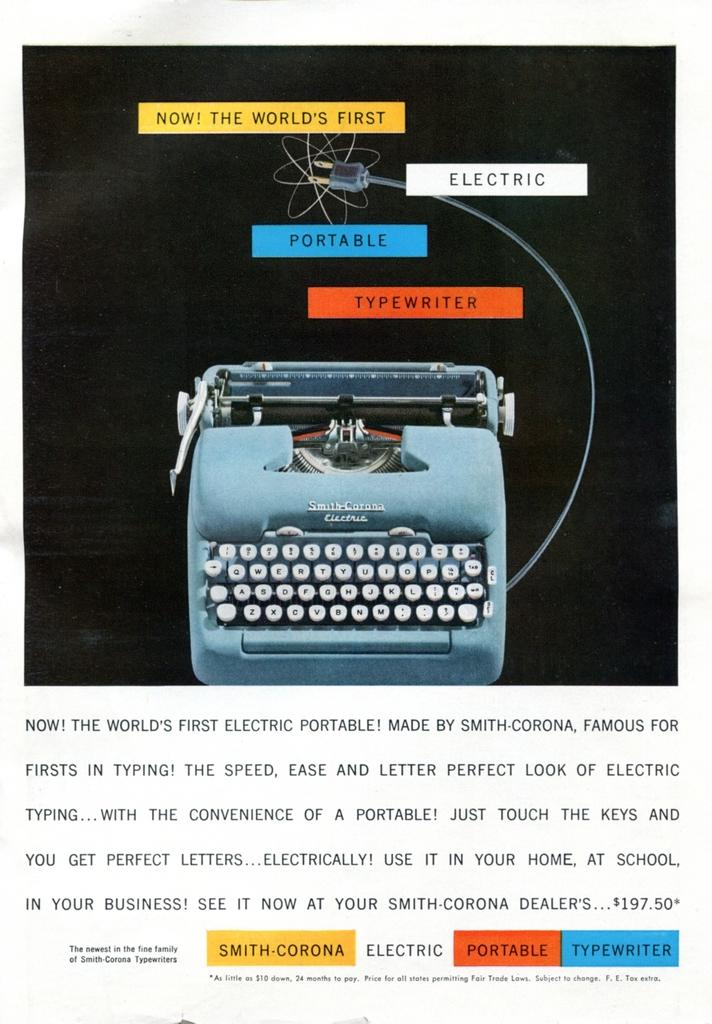<image>
Share a concise interpretation of the image provided. An advertisement for the Smith Corona Electric states that it is the world's first electric and portable typewriter. 